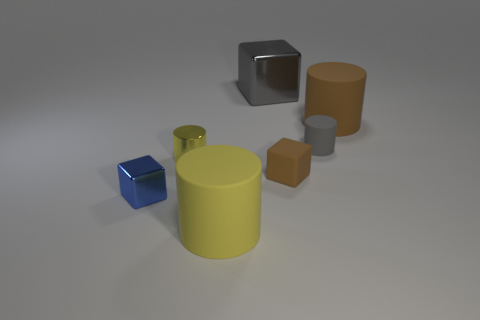Add 1 metallic cubes. How many objects exist? 8 Subtract all cubes. How many objects are left? 4 Add 3 brown rubber blocks. How many brown rubber blocks are left? 4 Add 5 large brown objects. How many large brown objects exist? 6 Subtract 0 purple balls. How many objects are left? 7 Subtract all big gray metal cylinders. Subtract all yellow things. How many objects are left? 5 